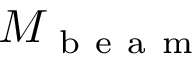<formula> <loc_0><loc_0><loc_500><loc_500>M _ { b e a m }</formula> 